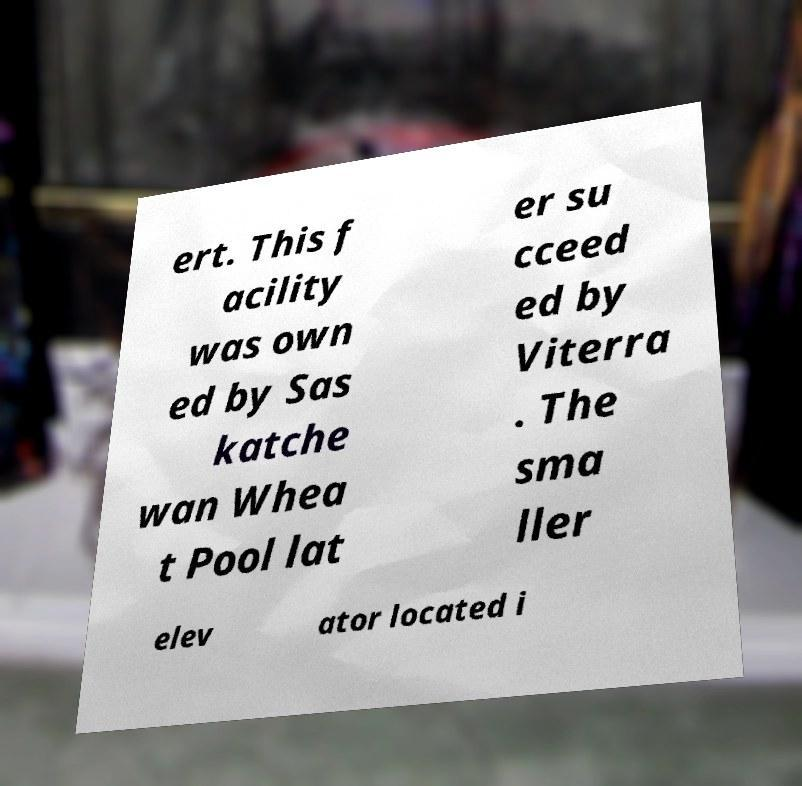Could you extract and type out the text from this image? ert. This f acility was own ed by Sas katche wan Whea t Pool lat er su cceed ed by Viterra . The sma ller elev ator located i 